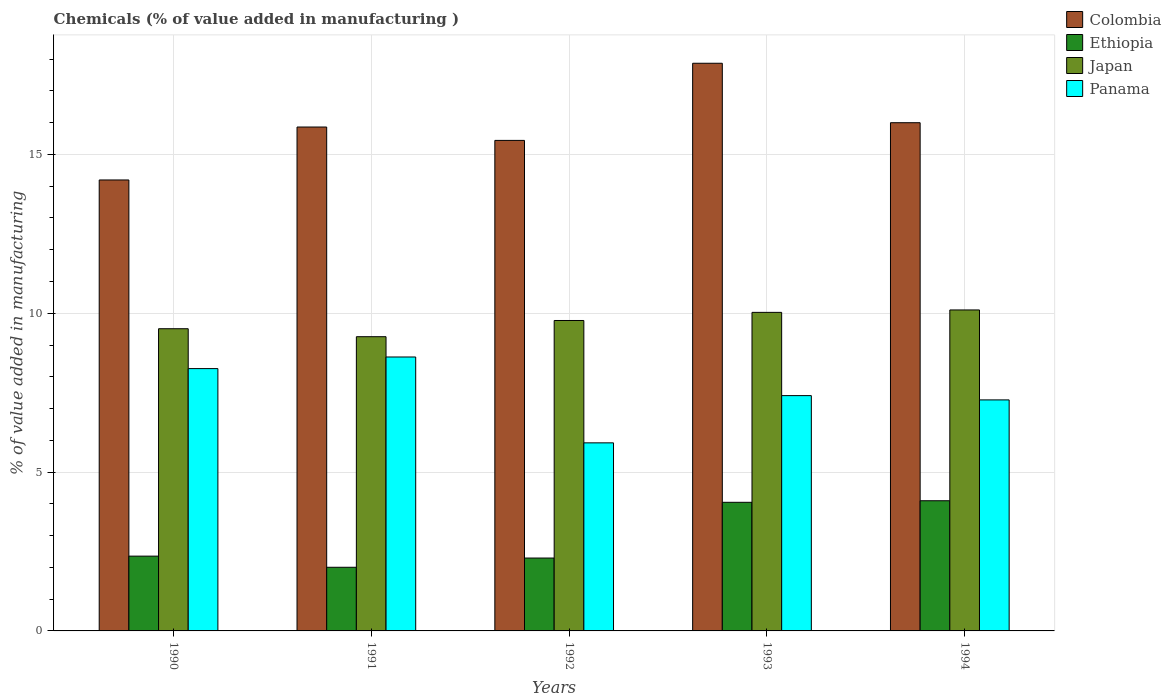How many different coloured bars are there?
Your response must be concise. 4. Are the number of bars per tick equal to the number of legend labels?
Your response must be concise. Yes. Are the number of bars on each tick of the X-axis equal?
Your answer should be very brief. Yes. How many bars are there on the 5th tick from the left?
Keep it short and to the point. 4. What is the value added in manufacturing chemicals in Panama in 1994?
Provide a short and direct response. 7.27. Across all years, what is the maximum value added in manufacturing chemicals in Panama?
Your response must be concise. 8.62. Across all years, what is the minimum value added in manufacturing chemicals in Japan?
Keep it short and to the point. 9.26. In which year was the value added in manufacturing chemicals in Japan maximum?
Provide a short and direct response. 1994. In which year was the value added in manufacturing chemicals in Ethiopia minimum?
Your response must be concise. 1991. What is the total value added in manufacturing chemicals in Colombia in the graph?
Offer a terse response. 79.37. What is the difference between the value added in manufacturing chemicals in Panama in 1990 and that in 1992?
Keep it short and to the point. 2.34. What is the difference between the value added in manufacturing chemicals in Colombia in 1993 and the value added in manufacturing chemicals in Panama in 1991?
Your answer should be very brief. 9.25. What is the average value added in manufacturing chemicals in Colombia per year?
Make the answer very short. 15.87. In the year 1994, what is the difference between the value added in manufacturing chemicals in Panama and value added in manufacturing chemicals in Ethiopia?
Ensure brevity in your answer.  3.17. What is the ratio of the value added in manufacturing chemicals in Panama in 1990 to that in 1992?
Ensure brevity in your answer.  1.39. Is the difference between the value added in manufacturing chemicals in Panama in 1990 and 1993 greater than the difference between the value added in manufacturing chemicals in Ethiopia in 1990 and 1993?
Provide a short and direct response. Yes. What is the difference between the highest and the second highest value added in manufacturing chemicals in Panama?
Your answer should be very brief. 0.37. What is the difference between the highest and the lowest value added in manufacturing chemicals in Colombia?
Keep it short and to the point. 3.67. In how many years, is the value added in manufacturing chemicals in Ethiopia greater than the average value added in manufacturing chemicals in Ethiopia taken over all years?
Make the answer very short. 2. Is the sum of the value added in manufacturing chemicals in Colombia in 1990 and 1993 greater than the maximum value added in manufacturing chemicals in Panama across all years?
Your answer should be compact. Yes. What does the 4th bar from the left in 1992 represents?
Your response must be concise. Panama. What does the 3rd bar from the right in 1992 represents?
Provide a short and direct response. Ethiopia. Is it the case that in every year, the sum of the value added in manufacturing chemicals in Colombia and value added in manufacturing chemicals in Ethiopia is greater than the value added in manufacturing chemicals in Panama?
Provide a short and direct response. Yes. How many bars are there?
Keep it short and to the point. 20. Does the graph contain grids?
Your response must be concise. Yes. Where does the legend appear in the graph?
Provide a succinct answer. Top right. How are the legend labels stacked?
Provide a short and direct response. Vertical. What is the title of the graph?
Offer a very short reply. Chemicals (% of value added in manufacturing ). What is the label or title of the Y-axis?
Provide a succinct answer. % of value added in manufacturing. What is the % of value added in manufacturing of Colombia in 1990?
Your response must be concise. 14.2. What is the % of value added in manufacturing of Ethiopia in 1990?
Your answer should be very brief. 2.35. What is the % of value added in manufacturing of Japan in 1990?
Keep it short and to the point. 9.51. What is the % of value added in manufacturing in Panama in 1990?
Offer a very short reply. 8.26. What is the % of value added in manufacturing in Colombia in 1991?
Your answer should be very brief. 15.86. What is the % of value added in manufacturing in Ethiopia in 1991?
Make the answer very short. 2. What is the % of value added in manufacturing in Japan in 1991?
Provide a succinct answer. 9.26. What is the % of value added in manufacturing in Panama in 1991?
Make the answer very short. 8.62. What is the % of value added in manufacturing in Colombia in 1992?
Offer a terse response. 15.44. What is the % of value added in manufacturing in Ethiopia in 1992?
Offer a terse response. 2.29. What is the % of value added in manufacturing in Japan in 1992?
Your answer should be compact. 9.77. What is the % of value added in manufacturing in Panama in 1992?
Offer a very short reply. 5.92. What is the % of value added in manufacturing in Colombia in 1993?
Provide a short and direct response. 17.87. What is the % of value added in manufacturing of Ethiopia in 1993?
Offer a very short reply. 4.05. What is the % of value added in manufacturing in Japan in 1993?
Give a very brief answer. 10.03. What is the % of value added in manufacturing of Panama in 1993?
Keep it short and to the point. 7.41. What is the % of value added in manufacturing of Colombia in 1994?
Keep it short and to the point. 16. What is the % of value added in manufacturing of Ethiopia in 1994?
Provide a succinct answer. 4.1. What is the % of value added in manufacturing of Japan in 1994?
Make the answer very short. 10.1. What is the % of value added in manufacturing of Panama in 1994?
Your answer should be compact. 7.27. Across all years, what is the maximum % of value added in manufacturing of Colombia?
Make the answer very short. 17.87. Across all years, what is the maximum % of value added in manufacturing of Ethiopia?
Your answer should be compact. 4.1. Across all years, what is the maximum % of value added in manufacturing in Japan?
Give a very brief answer. 10.1. Across all years, what is the maximum % of value added in manufacturing of Panama?
Ensure brevity in your answer.  8.62. Across all years, what is the minimum % of value added in manufacturing of Colombia?
Your answer should be compact. 14.2. Across all years, what is the minimum % of value added in manufacturing of Ethiopia?
Your answer should be very brief. 2. Across all years, what is the minimum % of value added in manufacturing in Japan?
Ensure brevity in your answer.  9.26. Across all years, what is the minimum % of value added in manufacturing in Panama?
Your response must be concise. 5.92. What is the total % of value added in manufacturing in Colombia in the graph?
Make the answer very short. 79.37. What is the total % of value added in manufacturing of Ethiopia in the graph?
Ensure brevity in your answer.  14.8. What is the total % of value added in manufacturing in Japan in the graph?
Provide a succinct answer. 48.68. What is the total % of value added in manufacturing of Panama in the graph?
Offer a very short reply. 37.48. What is the difference between the % of value added in manufacturing of Colombia in 1990 and that in 1991?
Offer a very short reply. -1.67. What is the difference between the % of value added in manufacturing of Ethiopia in 1990 and that in 1991?
Your answer should be very brief. 0.35. What is the difference between the % of value added in manufacturing of Japan in 1990 and that in 1991?
Provide a succinct answer. 0.25. What is the difference between the % of value added in manufacturing in Panama in 1990 and that in 1991?
Keep it short and to the point. -0.37. What is the difference between the % of value added in manufacturing in Colombia in 1990 and that in 1992?
Ensure brevity in your answer.  -1.25. What is the difference between the % of value added in manufacturing of Ethiopia in 1990 and that in 1992?
Your response must be concise. 0.06. What is the difference between the % of value added in manufacturing in Japan in 1990 and that in 1992?
Ensure brevity in your answer.  -0.26. What is the difference between the % of value added in manufacturing of Panama in 1990 and that in 1992?
Give a very brief answer. 2.34. What is the difference between the % of value added in manufacturing in Colombia in 1990 and that in 1993?
Your answer should be very brief. -3.67. What is the difference between the % of value added in manufacturing of Ethiopia in 1990 and that in 1993?
Offer a terse response. -1.69. What is the difference between the % of value added in manufacturing of Japan in 1990 and that in 1993?
Offer a terse response. -0.52. What is the difference between the % of value added in manufacturing of Panama in 1990 and that in 1993?
Offer a very short reply. 0.85. What is the difference between the % of value added in manufacturing of Colombia in 1990 and that in 1994?
Provide a short and direct response. -1.8. What is the difference between the % of value added in manufacturing of Ethiopia in 1990 and that in 1994?
Offer a very short reply. -1.74. What is the difference between the % of value added in manufacturing in Japan in 1990 and that in 1994?
Provide a short and direct response. -0.59. What is the difference between the % of value added in manufacturing of Panama in 1990 and that in 1994?
Keep it short and to the point. 0.99. What is the difference between the % of value added in manufacturing of Colombia in 1991 and that in 1992?
Your response must be concise. 0.42. What is the difference between the % of value added in manufacturing of Ethiopia in 1991 and that in 1992?
Your answer should be very brief. -0.29. What is the difference between the % of value added in manufacturing in Japan in 1991 and that in 1992?
Keep it short and to the point. -0.51. What is the difference between the % of value added in manufacturing of Panama in 1991 and that in 1992?
Your response must be concise. 2.7. What is the difference between the % of value added in manufacturing of Colombia in 1991 and that in 1993?
Provide a succinct answer. -2.01. What is the difference between the % of value added in manufacturing in Ethiopia in 1991 and that in 1993?
Your answer should be compact. -2.05. What is the difference between the % of value added in manufacturing of Japan in 1991 and that in 1993?
Your answer should be very brief. -0.77. What is the difference between the % of value added in manufacturing in Panama in 1991 and that in 1993?
Offer a very short reply. 1.22. What is the difference between the % of value added in manufacturing in Colombia in 1991 and that in 1994?
Offer a terse response. -0.14. What is the difference between the % of value added in manufacturing in Ethiopia in 1991 and that in 1994?
Give a very brief answer. -2.09. What is the difference between the % of value added in manufacturing of Japan in 1991 and that in 1994?
Provide a succinct answer. -0.84. What is the difference between the % of value added in manufacturing of Panama in 1991 and that in 1994?
Keep it short and to the point. 1.35. What is the difference between the % of value added in manufacturing of Colombia in 1992 and that in 1993?
Offer a very short reply. -2.43. What is the difference between the % of value added in manufacturing in Ethiopia in 1992 and that in 1993?
Offer a terse response. -1.75. What is the difference between the % of value added in manufacturing in Japan in 1992 and that in 1993?
Your answer should be compact. -0.26. What is the difference between the % of value added in manufacturing of Panama in 1992 and that in 1993?
Offer a very short reply. -1.49. What is the difference between the % of value added in manufacturing in Colombia in 1992 and that in 1994?
Offer a terse response. -0.56. What is the difference between the % of value added in manufacturing of Ethiopia in 1992 and that in 1994?
Provide a succinct answer. -1.8. What is the difference between the % of value added in manufacturing of Japan in 1992 and that in 1994?
Provide a short and direct response. -0.33. What is the difference between the % of value added in manufacturing of Panama in 1992 and that in 1994?
Provide a succinct answer. -1.35. What is the difference between the % of value added in manufacturing in Colombia in 1993 and that in 1994?
Offer a very short reply. 1.87. What is the difference between the % of value added in manufacturing of Ethiopia in 1993 and that in 1994?
Offer a very short reply. -0.05. What is the difference between the % of value added in manufacturing of Japan in 1993 and that in 1994?
Your answer should be compact. -0.08. What is the difference between the % of value added in manufacturing in Panama in 1993 and that in 1994?
Ensure brevity in your answer.  0.13. What is the difference between the % of value added in manufacturing of Colombia in 1990 and the % of value added in manufacturing of Ethiopia in 1991?
Give a very brief answer. 12.19. What is the difference between the % of value added in manufacturing of Colombia in 1990 and the % of value added in manufacturing of Japan in 1991?
Offer a very short reply. 4.93. What is the difference between the % of value added in manufacturing in Colombia in 1990 and the % of value added in manufacturing in Panama in 1991?
Offer a terse response. 5.57. What is the difference between the % of value added in manufacturing in Ethiopia in 1990 and the % of value added in manufacturing in Japan in 1991?
Ensure brevity in your answer.  -6.91. What is the difference between the % of value added in manufacturing in Ethiopia in 1990 and the % of value added in manufacturing in Panama in 1991?
Make the answer very short. -6.27. What is the difference between the % of value added in manufacturing in Japan in 1990 and the % of value added in manufacturing in Panama in 1991?
Your response must be concise. 0.89. What is the difference between the % of value added in manufacturing of Colombia in 1990 and the % of value added in manufacturing of Ethiopia in 1992?
Your response must be concise. 11.9. What is the difference between the % of value added in manufacturing in Colombia in 1990 and the % of value added in manufacturing in Japan in 1992?
Your response must be concise. 4.42. What is the difference between the % of value added in manufacturing in Colombia in 1990 and the % of value added in manufacturing in Panama in 1992?
Your answer should be compact. 8.28. What is the difference between the % of value added in manufacturing of Ethiopia in 1990 and the % of value added in manufacturing of Japan in 1992?
Give a very brief answer. -7.42. What is the difference between the % of value added in manufacturing in Ethiopia in 1990 and the % of value added in manufacturing in Panama in 1992?
Keep it short and to the point. -3.57. What is the difference between the % of value added in manufacturing of Japan in 1990 and the % of value added in manufacturing of Panama in 1992?
Your answer should be very brief. 3.59. What is the difference between the % of value added in manufacturing of Colombia in 1990 and the % of value added in manufacturing of Ethiopia in 1993?
Ensure brevity in your answer.  10.15. What is the difference between the % of value added in manufacturing in Colombia in 1990 and the % of value added in manufacturing in Japan in 1993?
Your response must be concise. 4.17. What is the difference between the % of value added in manufacturing of Colombia in 1990 and the % of value added in manufacturing of Panama in 1993?
Keep it short and to the point. 6.79. What is the difference between the % of value added in manufacturing in Ethiopia in 1990 and the % of value added in manufacturing in Japan in 1993?
Make the answer very short. -7.67. What is the difference between the % of value added in manufacturing in Ethiopia in 1990 and the % of value added in manufacturing in Panama in 1993?
Offer a terse response. -5.05. What is the difference between the % of value added in manufacturing of Japan in 1990 and the % of value added in manufacturing of Panama in 1993?
Offer a terse response. 2.11. What is the difference between the % of value added in manufacturing in Colombia in 1990 and the % of value added in manufacturing in Ethiopia in 1994?
Offer a terse response. 10.1. What is the difference between the % of value added in manufacturing in Colombia in 1990 and the % of value added in manufacturing in Japan in 1994?
Make the answer very short. 4.09. What is the difference between the % of value added in manufacturing in Colombia in 1990 and the % of value added in manufacturing in Panama in 1994?
Your answer should be compact. 6.92. What is the difference between the % of value added in manufacturing in Ethiopia in 1990 and the % of value added in manufacturing in Japan in 1994?
Make the answer very short. -7.75. What is the difference between the % of value added in manufacturing in Ethiopia in 1990 and the % of value added in manufacturing in Panama in 1994?
Offer a very short reply. -4.92. What is the difference between the % of value added in manufacturing in Japan in 1990 and the % of value added in manufacturing in Panama in 1994?
Offer a terse response. 2.24. What is the difference between the % of value added in manufacturing in Colombia in 1991 and the % of value added in manufacturing in Ethiopia in 1992?
Offer a terse response. 13.57. What is the difference between the % of value added in manufacturing in Colombia in 1991 and the % of value added in manufacturing in Japan in 1992?
Make the answer very short. 6.09. What is the difference between the % of value added in manufacturing in Colombia in 1991 and the % of value added in manufacturing in Panama in 1992?
Your answer should be compact. 9.94. What is the difference between the % of value added in manufacturing of Ethiopia in 1991 and the % of value added in manufacturing of Japan in 1992?
Offer a very short reply. -7.77. What is the difference between the % of value added in manufacturing in Ethiopia in 1991 and the % of value added in manufacturing in Panama in 1992?
Your answer should be very brief. -3.92. What is the difference between the % of value added in manufacturing of Japan in 1991 and the % of value added in manufacturing of Panama in 1992?
Your answer should be compact. 3.34. What is the difference between the % of value added in manufacturing of Colombia in 1991 and the % of value added in manufacturing of Ethiopia in 1993?
Offer a very short reply. 11.81. What is the difference between the % of value added in manufacturing of Colombia in 1991 and the % of value added in manufacturing of Japan in 1993?
Keep it short and to the point. 5.83. What is the difference between the % of value added in manufacturing of Colombia in 1991 and the % of value added in manufacturing of Panama in 1993?
Your response must be concise. 8.46. What is the difference between the % of value added in manufacturing in Ethiopia in 1991 and the % of value added in manufacturing in Japan in 1993?
Offer a terse response. -8.02. What is the difference between the % of value added in manufacturing of Ethiopia in 1991 and the % of value added in manufacturing of Panama in 1993?
Ensure brevity in your answer.  -5.4. What is the difference between the % of value added in manufacturing of Japan in 1991 and the % of value added in manufacturing of Panama in 1993?
Your answer should be compact. 1.85. What is the difference between the % of value added in manufacturing in Colombia in 1991 and the % of value added in manufacturing in Ethiopia in 1994?
Ensure brevity in your answer.  11.77. What is the difference between the % of value added in manufacturing of Colombia in 1991 and the % of value added in manufacturing of Japan in 1994?
Your response must be concise. 5.76. What is the difference between the % of value added in manufacturing of Colombia in 1991 and the % of value added in manufacturing of Panama in 1994?
Ensure brevity in your answer.  8.59. What is the difference between the % of value added in manufacturing of Ethiopia in 1991 and the % of value added in manufacturing of Japan in 1994?
Provide a short and direct response. -8.1. What is the difference between the % of value added in manufacturing of Ethiopia in 1991 and the % of value added in manufacturing of Panama in 1994?
Give a very brief answer. -5.27. What is the difference between the % of value added in manufacturing in Japan in 1991 and the % of value added in manufacturing in Panama in 1994?
Make the answer very short. 1.99. What is the difference between the % of value added in manufacturing of Colombia in 1992 and the % of value added in manufacturing of Ethiopia in 1993?
Your answer should be compact. 11.39. What is the difference between the % of value added in manufacturing in Colombia in 1992 and the % of value added in manufacturing in Japan in 1993?
Give a very brief answer. 5.41. What is the difference between the % of value added in manufacturing of Colombia in 1992 and the % of value added in manufacturing of Panama in 1993?
Your response must be concise. 8.03. What is the difference between the % of value added in manufacturing in Ethiopia in 1992 and the % of value added in manufacturing in Japan in 1993?
Make the answer very short. -7.73. What is the difference between the % of value added in manufacturing in Ethiopia in 1992 and the % of value added in manufacturing in Panama in 1993?
Offer a terse response. -5.11. What is the difference between the % of value added in manufacturing in Japan in 1992 and the % of value added in manufacturing in Panama in 1993?
Your answer should be very brief. 2.37. What is the difference between the % of value added in manufacturing in Colombia in 1992 and the % of value added in manufacturing in Ethiopia in 1994?
Your answer should be compact. 11.34. What is the difference between the % of value added in manufacturing of Colombia in 1992 and the % of value added in manufacturing of Japan in 1994?
Your answer should be very brief. 5.34. What is the difference between the % of value added in manufacturing of Colombia in 1992 and the % of value added in manufacturing of Panama in 1994?
Your response must be concise. 8.17. What is the difference between the % of value added in manufacturing of Ethiopia in 1992 and the % of value added in manufacturing of Japan in 1994?
Provide a short and direct response. -7.81. What is the difference between the % of value added in manufacturing of Ethiopia in 1992 and the % of value added in manufacturing of Panama in 1994?
Offer a terse response. -4.98. What is the difference between the % of value added in manufacturing of Japan in 1992 and the % of value added in manufacturing of Panama in 1994?
Offer a very short reply. 2.5. What is the difference between the % of value added in manufacturing in Colombia in 1993 and the % of value added in manufacturing in Ethiopia in 1994?
Provide a short and direct response. 13.77. What is the difference between the % of value added in manufacturing in Colombia in 1993 and the % of value added in manufacturing in Japan in 1994?
Your answer should be compact. 7.77. What is the difference between the % of value added in manufacturing in Colombia in 1993 and the % of value added in manufacturing in Panama in 1994?
Provide a succinct answer. 10.6. What is the difference between the % of value added in manufacturing of Ethiopia in 1993 and the % of value added in manufacturing of Japan in 1994?
Keep it short and to the point. -6.06. What is the difference between the % of value added in manufacturing in Ethiopia in 1993 and the % of value added in manufacturing in Panama in 1994?
Make the answer very short. -3.22. What is the difference between the % of value added in manufacturing in Japan in 1993 and the % of value added in manufacturing in Panama in 1994?
Your answer should be compact. 2.76. What is the average % of value added in manufacturing of Colombia per year?
Your answer should be compact. 15.87. What is the average % of value added in manufacturing of Ethiopia per year?
Your answer should be very brief. 2.96. What is the average % of value added in manufacturing of Japan per year?
Make the answer very short. 9.74. What is the average % of value added in manufacturing of Panama per year?
Make the answer very short. 7.5. In the year 1990, what is the difference between the % of value added in manufacturing in Colombia and % of value added in manufacturing in Ethiopia?
Ensure brevity in your answer.  11.84. In the year 1990, what is the difference between the % of value added in manufacturing of Colombia and % of value added in manufacturing of Japan?
Offer a very short reply. 4.68. In the year 1990, what is the difference between the % of value added in manufacturing in Colombia and % of value added in manufacturing in Panama?
Provide a succinct answer. 5.94. In the year 1990, what is the difference between the % of value added in manufacturing of Ethiopia and % of value added in manufacturing of Japan?
Give a very brief answer. -7.16. In the year 1990, what is the difference between the % of value added in manufacturing in Ethiopia and % of value added in manufacturing in Panama?
Ensure brevity in your answer.  -5.9. In the year 1990, what is the difference between the % of value added in manufacturing of Japan and % of value added in manufacturing of Panama?
Your answer should be very brief. 1.26. In the year 1991, what is the difference between the % of value added in manufacturing in Colombia and % of value added in manufacturing in Ethiopia?
Ensure brevity in your answer.  13.86. In the year 1991, what is the difference between the % of value added in manufacturing in Colombia and % of value added in manufacturing in Japan?
Offer a very short reply. 6.6. In the year 1991, what is the difference between the % of value added in manufacturing of Colombia and % of value added in manufacturing of Panama?
Give a very brief answer. 7.24. In the year 1991, what is the difference between the % of value added in manufacturing in Ethiopia and % of value added in manufacturing in Japan?
Provide a succinct answer. -7.26. In the year 1991, what is the difference between the % of value added in manufacturing of Ethiopia and % of value added in manufacturing of Panama?
Your response must be concise. -6.62. In the year 1991, what is the difference between the % of value added in manufacturing of Japan and % of value added in manufacturing of Panama?
Your answer should be compact. 0.64. In the year 1992, what is the difference between the % of value added in manufacturing of Colombia and % of value added in manufacturing of Ethiopia?
Your response must be concise. 13.15. In the year 1992, what is the difference between the % of value added in manufacturing of Colombia and % of value added in manufacturing of Japan?
Offer a terse response. 5.67. In the year 1992, what is the difference between the % of value added in manufacturing in Colombia and % of value added in manufacturing in Panama?
Offer a very short reply. 9.52. In the year 1992, what is the difference between the % of value added in manufacturing in Ethiopia and % of value added in manufacturing in Japan?
Provide a short and direct response. -7.48. In the year 1992, what is the difference between the % of value added in manufacturing in Ethiopia and % of value added in manufacturing in Panama?
Provide a short and direct response. -3.63. In the year 1992, what is the difference between the % of value added in manufacturing in Japan and % of value added in manufacturing in Panama?
Keep it short and to the point. 3.85. In the year 1993, what is the difference between the % of value added in manufacturing of Colombia and % of value added in manufacturing of Ethiopia?
Provide a succinct answer. 13.82. In the year 1993, what is the difference between the % of value added in manufacturing in Colombia and % of value added in manufacturing in Japan?
Offer a very short reply. 7.84. In the year 1993, what is the difference between the % of value added in manufacturing of Colombia and % of value added in manufacturing of Panama?
Keep it short and to the point. 10.46. In the year 1993, what is the difference between the % of value added in manufacturing of Ethiopia and % of value added in manufacturing of Japan?
Your response must be concise. -5.98. In the year 1993, what is the difference between the % of value added in manufacturing of Ethiopia and % of value added in manufacturing of Panama?
Your response must be concise. -3.36. In the year 1993, what is the difference between the % of value added in manufacturing of Japan and % of value added in manufacturing of Panama?
Your answer should be compact. 2.62. In the year 1994, what is the difference between the % of value added in manufacturing in Colombia and % of value added in manufacturing in Ethiopia?
Provide a succinct answer. 11.9. In the year 1994, what is the difference between the % of value added in manufacturing of Colombia and % of value added in manufacturing of Japan?
Provide a succinct answer. 5.89. In the year 1994, what is the difference between the % of value added in manufacturing of Colombia and % of value added in manufacturing of Panama?
Ensure brevity in your answer.  8.73. In the year 1994, what is the difference between the % of value added in manufacturing in Ethiopia and % of value added in manufacturing in Japan?
Keep it short and to the point. -6.01. In the year 1994, what is the difference between the % of value added in manufacturing of Ethiopia and % of value added in manufacturing of Panama?
Your response must be concise. -3.17. In the year 1994, what is the difference between the % of value added in manufacturing of Japan and % of value added in manufacturing of Panama?
Offer a very short reply. 2.83. What is the ratio of the % of value added in manufacturing in Colombia in 1990 to that in 1991?
Make the answer very short. 0.89. What is the ratio of the % of value added in manufacturing in Ethiopia in 1990 to that in 1991?
Make the answer very short. 1.17. What is the ratio of the % of value added in manufacturing of Japan in 1990 to that in 1991?
Provide a short and direct response. 1.03. What is the ratio of the % of value added in manufacturing in Panama in 1990 to that in 1991?
Ensure brevity in your answer.  0.96. What is the ratio of the % of value added in manufacturing of Colombia in 1990 to that in 1992?
Keep it short and to the point. 0.92. What is the ratio of the % of value added in manufacturing of Ethiopia in 1990 to that in 1992?
Provide a succinct answer. 1.03. What is the ratio of the % of value added in manufacturing of Japan in 1990 to that in 1992?
Your answer should be very brief. 0.97. What is the ratio of the % of value added in manufacturing in Panama in 1990 to that in 1992?
Your answer should be very brief. 1.39. What is the ratio of the % of value added in manufacturing of Colombia in 1990 to that in 1993?
Your answer should be very brief. 0.79. What is the ratio of the % of value added in manufacturing of Ethiopia in 1990 to that in 1993?
Your answer should be very brief. 0.58. What is the ratio of the % of value added in manufacturing of Japan in 1990 to that in 1993?
Make the answer very short. 0.95. What is the ratio of the % of value added in manufacturing in Panama in 1990 to that in 1993?
Make the answer very short. 1.11. What is the ratio of the % of value added in manufacturing of Colombia in 1990 to that in 1994?
Offer a very short reply. 0.89. What is the ratio of the % of value added in manufacturing in Ethiopia in 1990 to that in 1994?
Provide a short and direct response. 0.57. What is the ratio of the % of value added in manufacturing in Japan in 1990 to that in 1994?
Offer a very short reply. 0.94. What is the ratio of the % of value added in manufacturing in Panama in 1990 to that in 1994?
Your answer should be compact. 1.14. What is the ratio of the % of value added in manufacturing of Colombia in 1991 to that in 1992?
Keep it short and to the point. 1.03. What is the ratio of the % of value added in manufacturing of Ethiopia in 1991 to that in 1992?
Your answer should be very brief. 0.87. What is the ratio of the % of value added in manufacturing in Japan in 1991 to that in 1992?
Give a very brief answer. 0.95. What is the ratio of the % of value added in manufacturing in Panama in 1991 to that in 1992?
Provide a succinct answer. 1.46. What is the ratio of the % of value added in manufacturing in Colombia in 1991 to that in 1993?
Your response must be concise. 0.89. What is the ratio of the % of value added in manufacturing in Ethiopia in 1991 to that in 1993?
Offer a very short reply. 0.49. What is the ratio of the % of value added in manufacturing of Japan in 1991 to that in 1993?
Your answer should be compact. 0.92. What is the ratio of the % of value added in manufacturing of Panama in 1991 to that in 1993?
Your response must be concise. 1.16. What is the ratio of the % of value added in manufacturing in Ethiopia in 1991 to that in 1994?
Offer a terse response. 0.49. What is the ratio of the % of value added in manufacturing of Japan in 1991 to that in 1994?
Your response must be concise. 0.92. What is the ratio of the % of value added in manufacturing in Panama in 1991 to that in 1994?
Your answer should be very brief. 1.19. What is the ratio of the % of value added in manufacturing of Colombia in 1992 to that in 1993?
Your response must be concise. 0.86. What is the ratio of the % of value added in manufacturing in Ethiopia in 1992 to that in 1993?
Offer a very short reply. 0.57. What is the ratio of the % of value added in manufacturing in Japan in 1992 to that in 1993?
Give a very brief answer. 0.97. What is the ratio of the % of value added in manufacturing of Panama in 1992 to that in 1993?
Make the answer very short. 0.8. What is the ratio of the % of value added in manufacturing of Colombia in 1992 to that in 1994?
Make the answer very short. 0.97. What is the ratio of the % of value added in manufacturing of Ethiopia in 1992 to that in 1994?
Your answer should be compact. 0.56. What is the ratio of the % of value added in manufacturing of Japan in 1992 to that in 1994?
Make the answer very short. 0.97. What is the ratio of the % of value added in manufacturing of Panama in 1992 to that in 1994?
Your answer should be very brief. 0.81. What is the ratio of the % of value added in manufacturing in Colombia in 1993 to that in 1994?
Your answer should be compact. 1.12. What is the ratio of the % of value added in manufacturing of Ethiopia in 1993 to that in 1994?
Your response must be concise. 0.99. What is the ratio of the % of value added in manufacturing of Panama in 1993 to that in 1994?
Your answer should be compact. 1.02. What is the difference between the highest and the second highest % of value added in manufacturing in Colombia?
Your response must be concise. 1.87. What is the difference between the highest and the second highest % of value added in manufacturing of Ethiopia?
Your answer should be very brief. 0.05. What is the difference between the highest and the second highest % of value added in manufacturing of Japan?
Provide a succinct answer. 0.08. What is the difference between the highest and the second highest % of value added in manufacturing in Panama?
Provide a succinct answer. 0.37. What is the difference between the highest and the lowest % of value added in manufacturing in Colombia?
Your answer should be compact. 3.67. What is the difference between the highest and the lowest % of value added in manufacturing in Ethiopia?
Give a very brief answer. 2.09. What is the difference between the highest and the lowest % of value added in manufacturing of Japan?
Ensure brevity in your answer.  0.84. What is the difference between the highest and the lowest % of value added in manufacturing of Panama?
Provide a succinct answer. 2.7. 